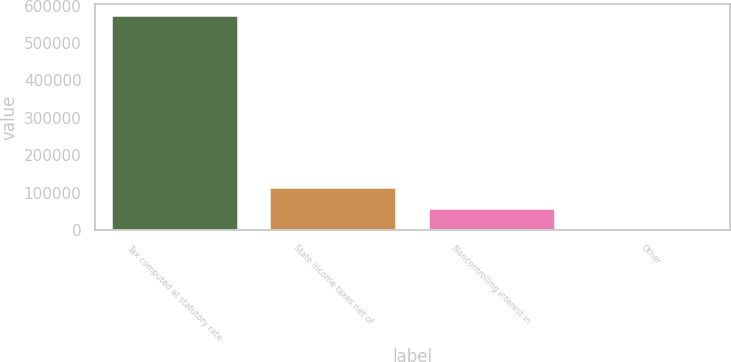<chart> <loc_0><loc_0><loc_500><loc_500><bar_chart><fcel>Tax computed at statutory rate<fcel>State income taxes net of<fcel>Noncontrolling interest in<fcel>Other<nl><fcel>574682<fcel>116188<fcel>58876.7<fcel>1565<nl></chart> 